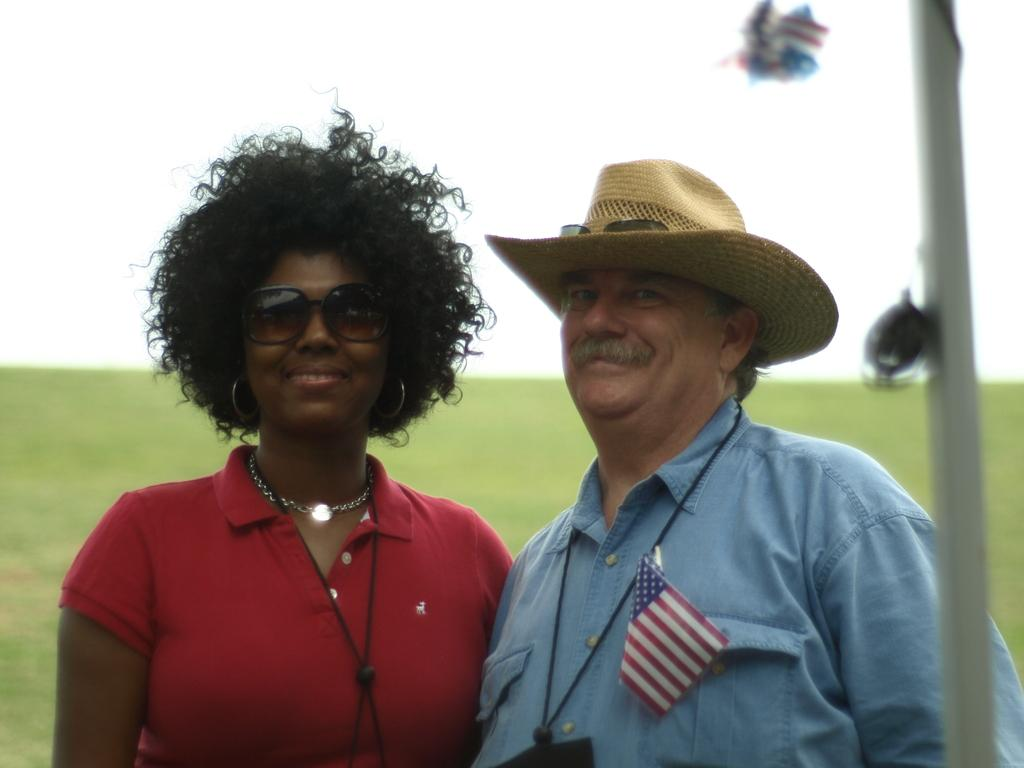How many people are in the image? There are two people in the image. What is the facial expression of the people in the image? The people are smiling. What is one object in the image that is related to a country or organization? There is a flag in the image. What type of headwear is visible in the image? There is a hat in the image. What type of protective eyewear is visible in the image? There are goggles in the image. What type of natural environment is visible in the background of the image? The background of the image includes grass. What part of the natural environment is visible in the background of the image? The sky is visible in the background of the image. What type of attraction can be seen in the image? There is no specific attraction mentioned or visible in the image. 